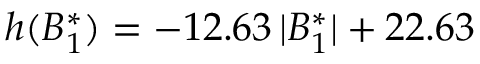<formula> <loc_0><loc_0><loc_500><loc_500>h ( B _ { 1 } ^ { * } ) = - 1 2 . 6 3 \, | B _ { 1 } ^ { * } | + 2 2 . 6 3</formula> 